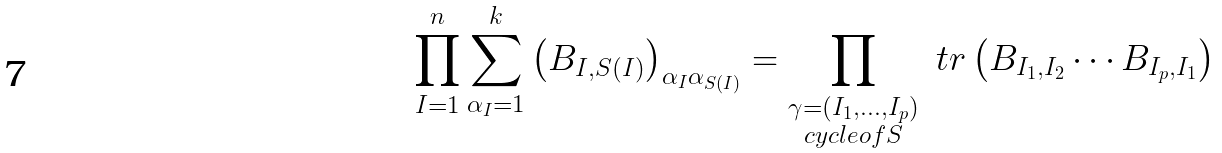<formula> <loc_0><loc_0><loc_500><loc_500>\prod _ { I = 1 } ^ { n } \sum _ { \alpha _ { I } = 1 } ^ { k } \left ( B _ { I , S ( I ) } \right ) _ { \alpha _ { I } \alpha _ { S ( I ) } } = \prod _ { \substack { \gamma = ( I _ { 1 } , \dots , I _ { p } ) \\ c y c l e o f S } } \ t r \left ( B _ { I _ { 1 } , I _ { 2 } } \cdots B _ { I _ { p } , I _ { 1 } } \right )</formula> 